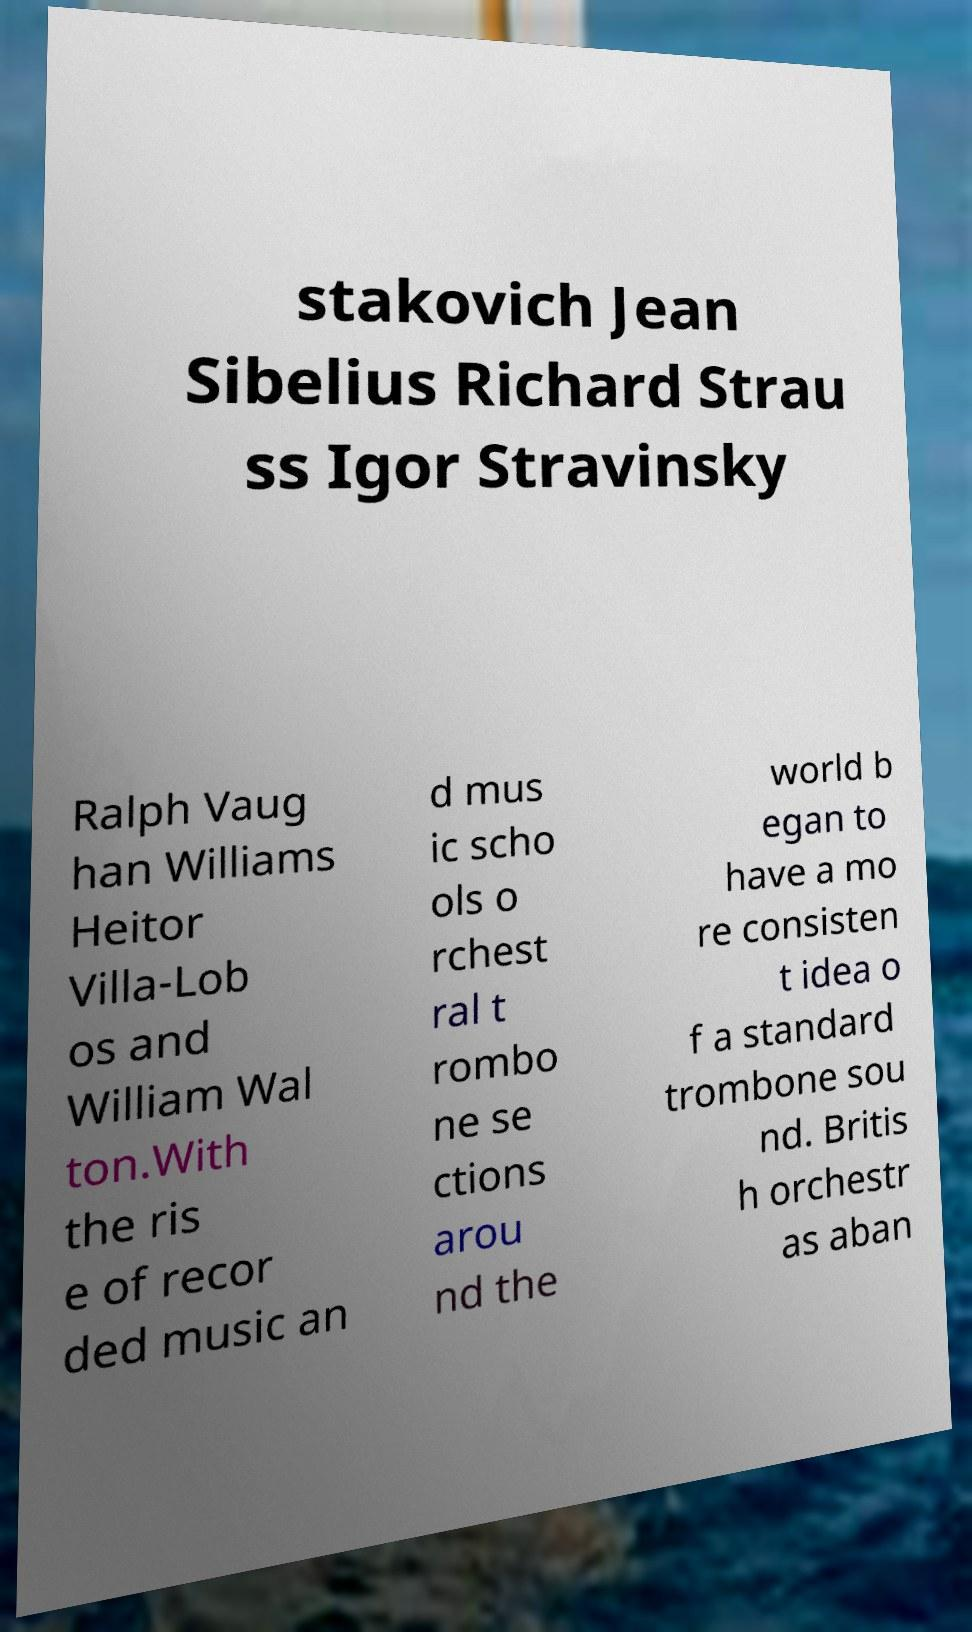I need the written content from this picture converted into text. Can you do that? stakovich Jean Sibelius Richard Strau ss Igor Stravinsky Ralph Vaug han Williams Heitor Villa-Lob os and William Wal ton.With the ris e of recor ded music an d mus ic scho ols o rchest ral t rombo ne se ctions arou nd the world b egan to have a mo re consisten t idea o f a standard trombone sou nd. Britis h orchestr as aban 